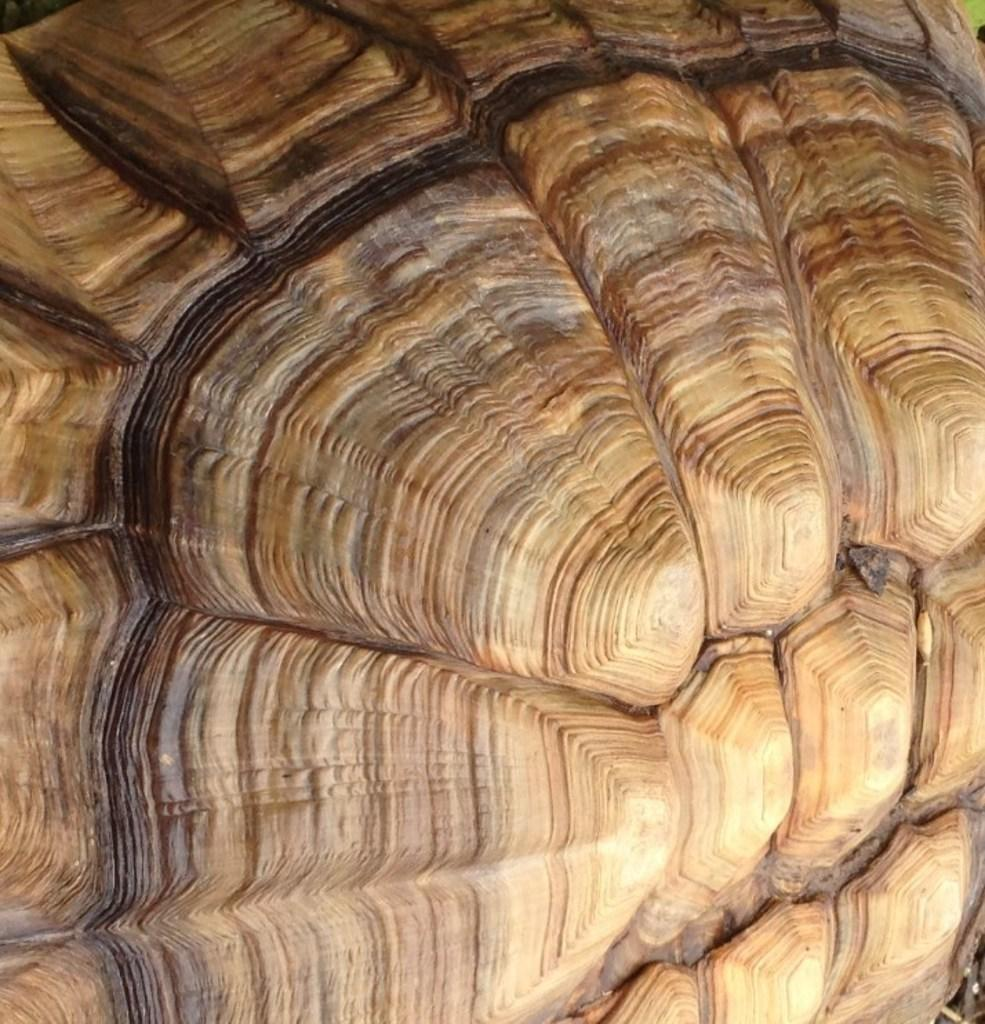What is the main object in the image that resembles a rock? There is an object in the image that looks like a rock. How many objects on the ground in the image resemble rocks? There are two objects on the ground in the image that look like rocks. Where can objects be found in the top right side corner of the image? There are objects in the top right side corner of the image. Where can objects be found in the bottom right side corner of the image? There are objects in the bottom right side right side corner of the image. What is the development of the argument between the toes in the image? There are no toes or arguments present in the image; it features objects that resemble rocks and other unspecified objects in the corners. 